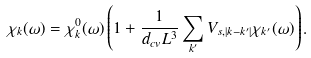<formula> <loc_0><loc_0><loc_500><loc_500>\chi _ { k } ( \omega ) = \chi _ { k } ^ { 0 } ( \omega ) \left ( 1 + \frac { 1 } { d _ { c v } L ^ { 3 } } \sum _ { k ^ { \prime } } V _ { s , | k - k ^ { \prime } | } \chi _ { k ^ { \prime } } ( \omega ) \right ) .</formula> 